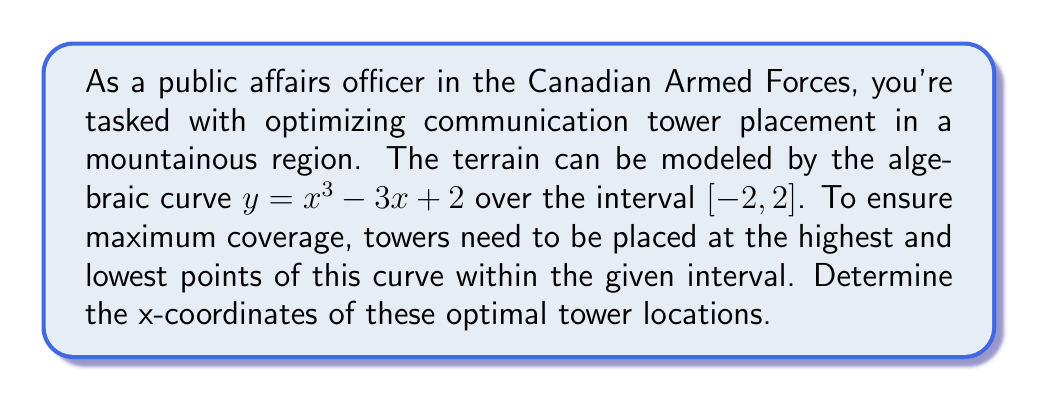Can you answer this question? To find the optimal tower locations, we need to determine the local maximum and minimum points of the curve $y = x^3 - 3x + 2$ within the interval $[-2, 2]$. These points occur where the first derivative of the function is zero.

Step 1: Find the first derivative of the function.
$$\frac{dy}{dx} = 3x^2 - 3$$

Step 2: Set the first derivative equal to zero and solve for x.
$$3x^2 - 3 = 0$$
$$3x^2 = 3$$
$$x^2 = 1$$
$$x = \pm 1$$

Step 3: Verify that these critical points fall within the given interval $[-2, 2]$.
Both $x = -1$ and $x = 1$ are within the interval.

Step 4: Evaluate the original function at these critical points to determine which is the maximum and which is the minimum.
For $x = -1$: $y = (-1)^3 - 3(-1) + 2 = -1 + 3 + 2 = 4$
For $x = 1$: $y = (1)^3 - 3(1) + 2 = 1 - 3 + 2 = 0$

Step 5: Check the endpoints of the interval to ensure they are not extrema.
For $x = -2$: $y = (-2)^3 - 3(-2) + 2 = -8 + 6 + 2 = 0$
For $x = 2$: $y = (2)^3 - 3(2) + 2 = 8 - 6 + 2 = 4$

Therefore, the highest point occurs at $x = -1$ and the lowest point occurs at $x = 1$.
Answer: $x = -1$ and $x = 1$ 